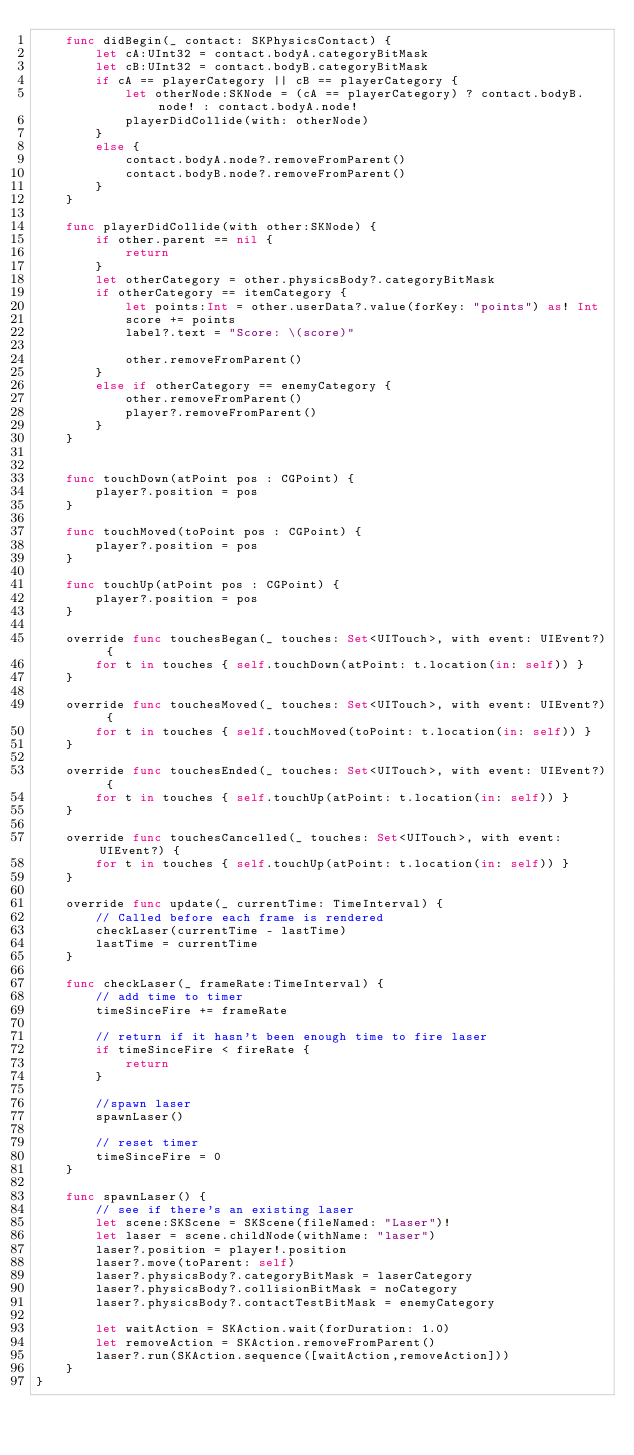Convert code to text. <code><loc_0><loc_0><loc_500><loc_500><_Swift_>    func didBegin(_ contact: SKPhysicsContact) {
        let cA:UInt32 = contact.bodyA.categoryBitMask
        let cB:UInt32 = contact.bodyB.categoryBitMask
        if cA == playerCategory || cB == playerCategory {
            let otherNode:SKNode = (cA == playerCategory) ? contact.bodyB.node! : contact.bodyA.node!
            playerDidCollide(with: otherNode)
        }
        else {
            contact.bodyA.node?.removeFromParent()
            contact.bodyB.node?.removeFromParent()
        }
    }
    
    func playerDidCollide(with other:SKNode) {
        if other.parent == nil {
            return
        }
        let otherCategory = other.physicsBody?.categoryBitMask
        if otherCategory == itemCategory {
            let points:Int = other.userData?.value(forKey: "points") as! Int
            score += points
            label?.text = "Score: \(score)"
            
            other.removeFromParent()
        }
        else if otherCategory == enemyCategory {
            other.removeFromParent()
            player?.removeFromParent()
        }
    }
    
    
    func touchDown(atPoint pos : CGPoint) {
        player?.position = pos
    }
    
    func touchMoved(toPoint pos : CGPoint) {
        player?.position = pos
    }
    
    func touchUp(atPoint pos : CGPoint) {
        player?.position = pos
    }
    
    override func touchesBegan(_ touches: Set<UITouch>, with event: UIEvent?) {
        for t in touches { self.touchDown(atPoint: t.location(in: self)) }
    }
    
    override func touchesMoved(_ touches: Set<UITouch>, with event: UIEvent?) {
        for t in touches { self.touchMoved(toPoint: t.location(in: self)) }
    }
    
    override func touchesEnded(_ touches: Set<UITouch>, with event: UIEvent?) {
        for t in touches { self.touchUp(atPoint: t.location(in: self)) }
    }
    
    override func touchesCancelled(_ touches: Set<UITouch>, with event: UIEvent?) {
        for t in touches { self.touchUp(atPoint: t.location(in: self)) }
    }
    
    override func update(_ currentTime: TimeInterval) {
        // Called before each frame is rendered
        checkLaser(currentTime - lastTime)
        lastTime = currentTime
    }
    
    func checkLaser(_ frameRate:TimeInterval) {
        // add time to timer
        timeSinceFire += frameRate
        
        // return if it hasn't been enough time to fire laser
        if timeSinceFire < fireRate {
            return
        }
        
        //spawn laser
        spawnLaser()
        
        // reset timer
        timeSinceFire = 0
    }
    
    func spawnLaser() {
        // see if there's an existing laser
        let scene:SKScene = SKScene(fileNamed: "Laser")!
        let laser = scene.childNode(withName: "laser")
        laser?.position = player!.position
        laser?.move(toParent: self)
        laser?.physicsBody?.categoryBitMask = laserCategory
        laser?.physicsBody?.collisionBitMask = noCategory
        laser?.physicsBody?.contactTestBitMask = enemyCategory
        
        let waitAction = SKAction.wait(forDuration: 1.0)
        let removeAction = SKAction.removeFromParent()
        laser?.run(SKAction.sequence([waitAction,removeAction]))
    }
}
</code> 